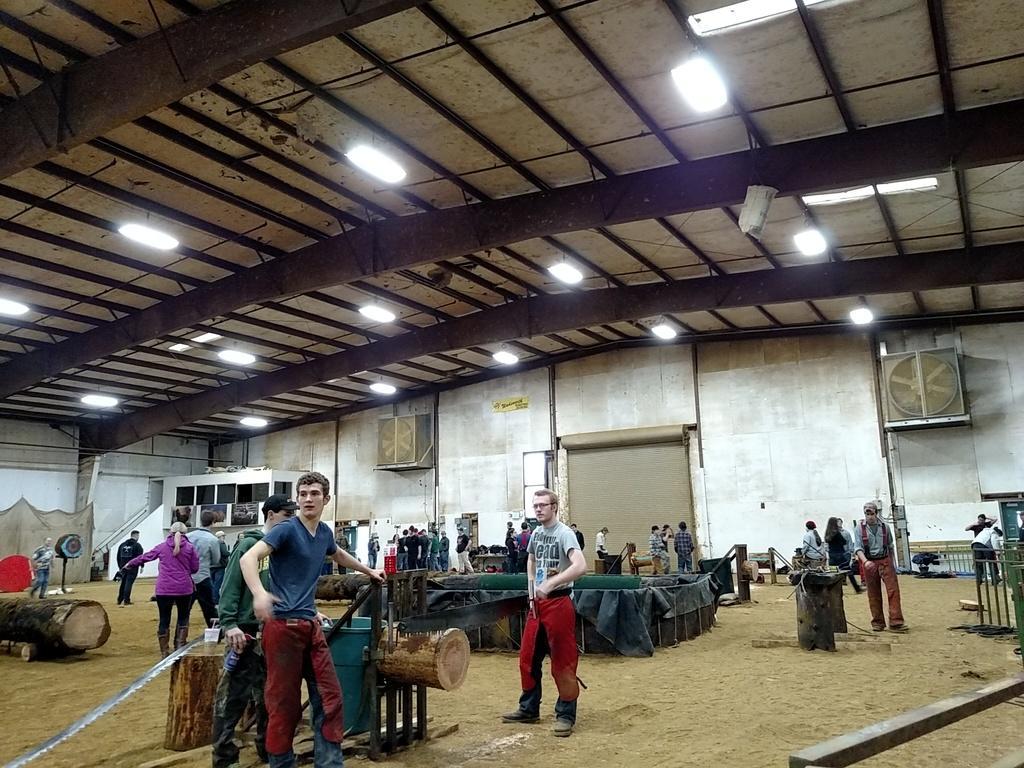How would you summarize this image in a sentence or two? In this image we can see many people. Also there are wood cutting machines and there are wooden logs. On the ceiling there are lights. In the back there is a wall. And there are exhaust fans. Also there is a saw. 